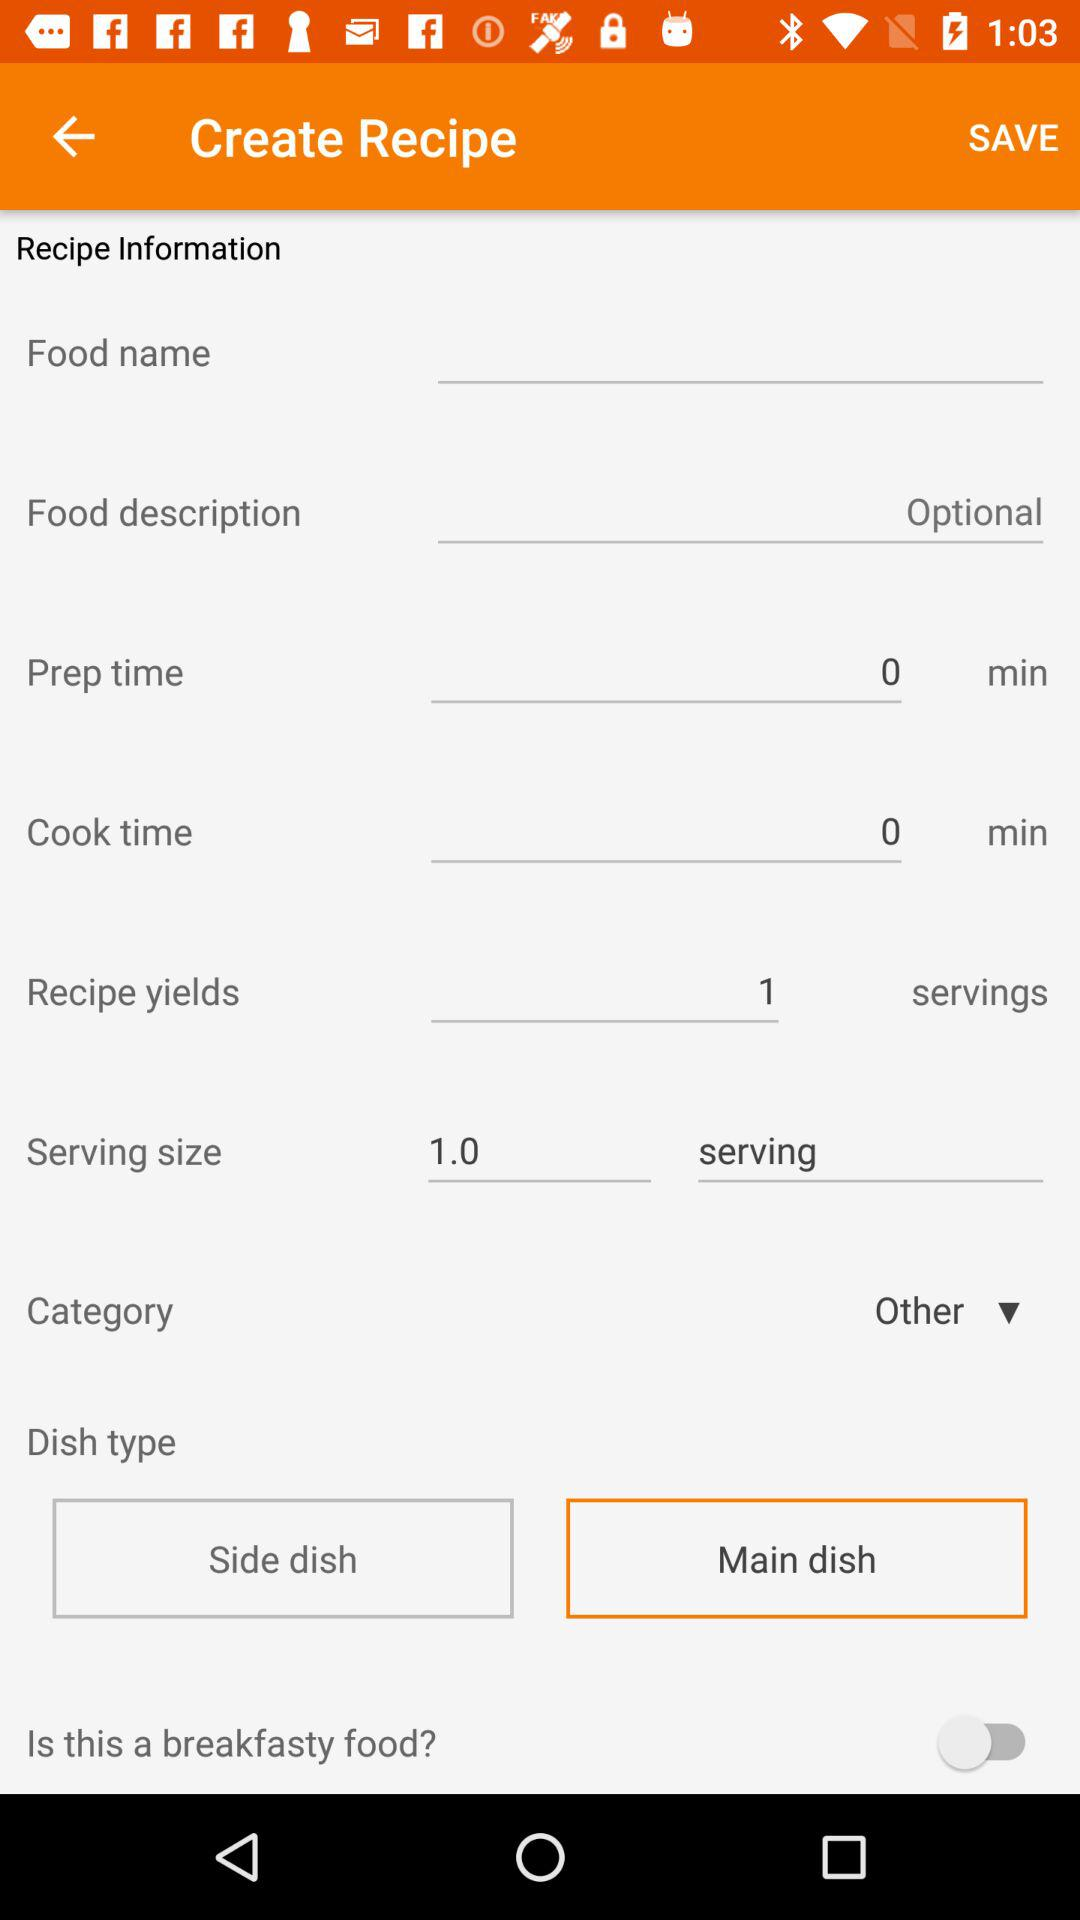What does the recipe yield? The recipe yields only 1 serving. 